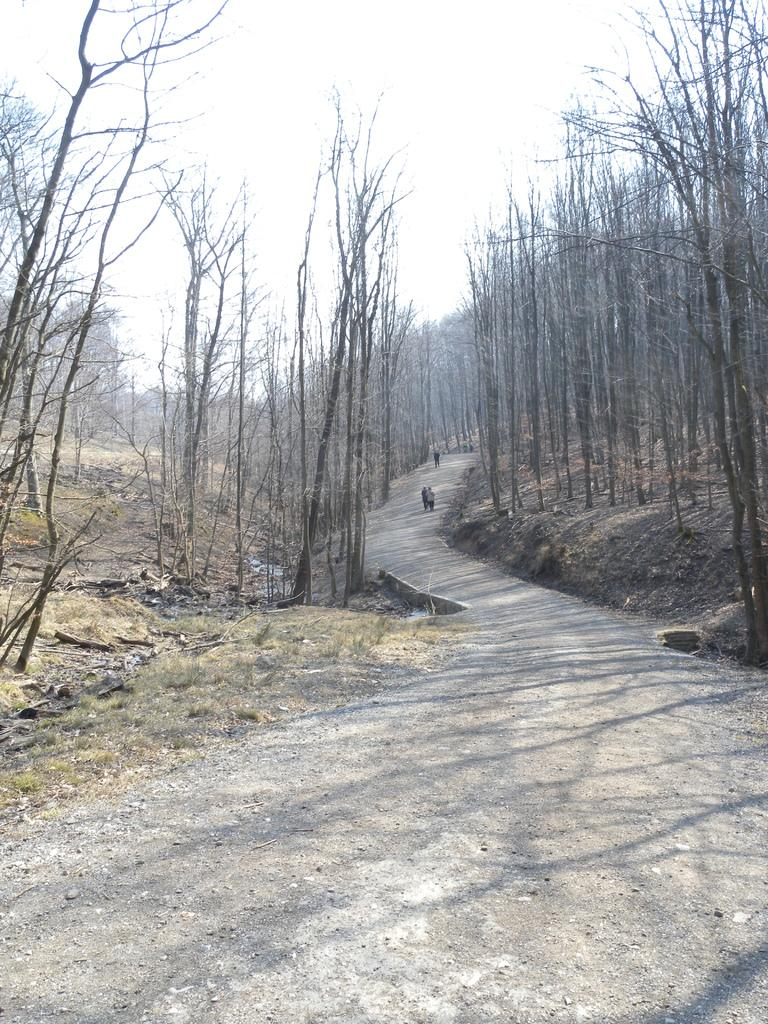What is happening in the center of the image? There is a group of persons standing on the road in the center of the image. What can be seen in the background of the image? There is a group of trees and grass in the background, as well as the sky. What type of iron is being used by the persons in the image? There is no iron present in the image; it features a group of persons standing on the road. Can you see any wings on the persons in the image? There are no wings visible on the persons in the image. 